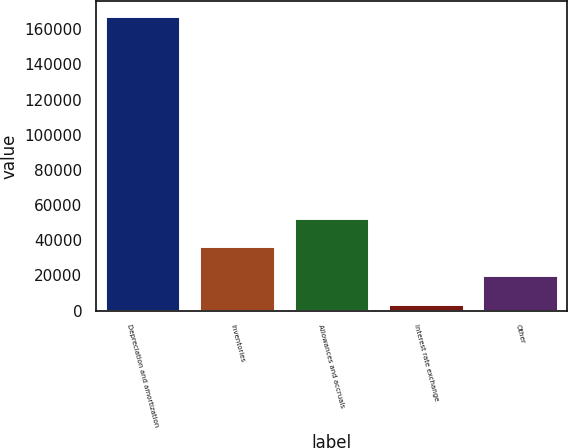<chart> <loc_0><loc_0><loc_500><loc_500><bar_chart><fcel>Depreciation and amortization<fcel>Inventories<fcel>Allowances and accruals<fcel>Interest rate exchange<fcel>Other<nl><fcel>167345<fcel>36495.4<fcel>52851.6<fcel>3783<fcel>20139.2<nl></chart> 